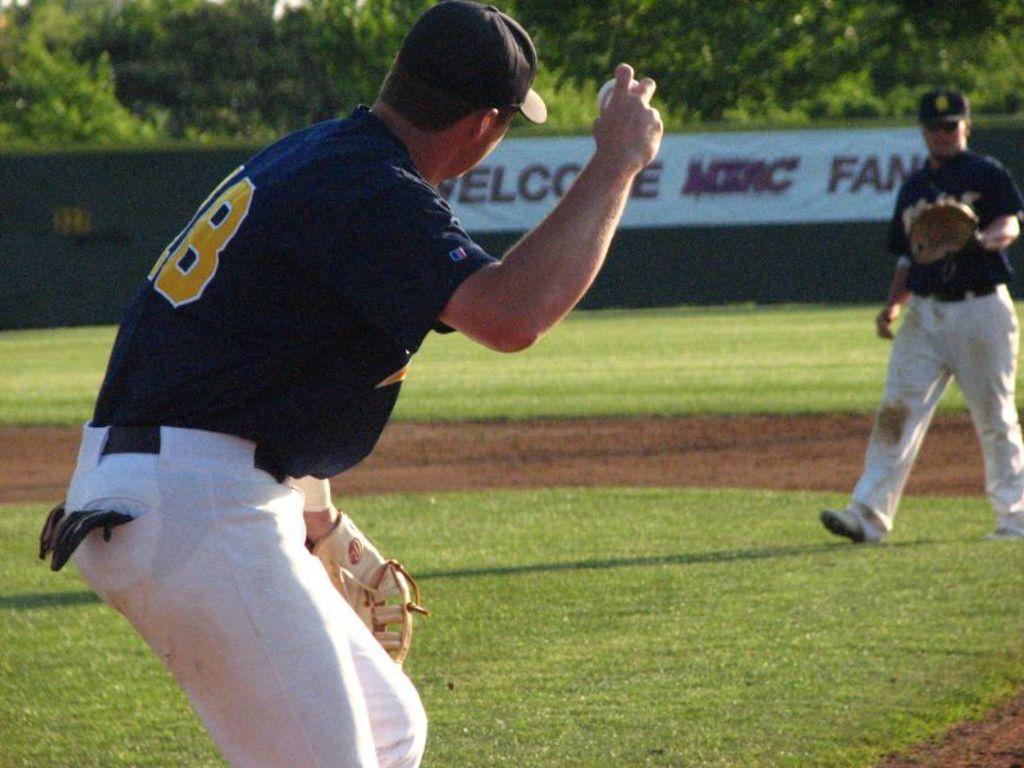Describe this image in one or two sentences. In this image there is a person wearing sports dress is holding a ball in his hand. He is wearing a cap. Right side there is a person walking on the grassland. He is wearing gloves and cap. Behind them there is a banner. Top of image there are few trees. 